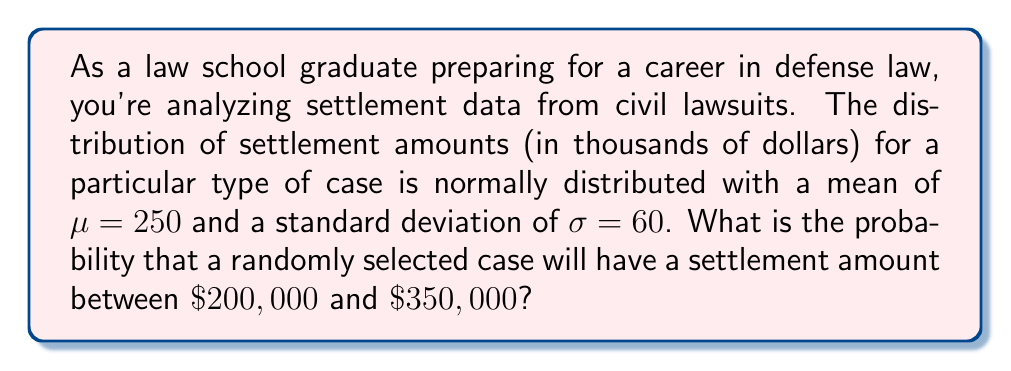Solve this math problem. To solve this problem, we'll use the properties of the normal distribution and the concept of z-scores.

1) First, we need to standardize the given values to calculate z-scores:

   For $\$200,000$: $z_1 = \frac{200 - 250}{60} = -\frac{50}{60} = -0.8333$
   For $\$350,000$: $z_2 = \frac{350 - 250}{60} = \frac{100}{60} = 1.6667$

2) Now, we need to find the area under the standard normal curve between these two z-scores.

3) We can use a standard normal table or a calculator to find the cumulative probability for each z-score:

   $P(Z \leq -0.8333) \approx 0.2023$
   $P(Z \leq 1.6667) \approx 0.9522$

4) The probability we're looking for is the difference between these two values:

   $P(-0.8333 \leq Z \leq 1.6667) = 0.9522 - 0.2023 = 0.7499$

5) Therefore, the probability that a randomly selected case will have a settlement amount between $\$200,000$ and $\$350,000$ is approximately 0.7499 or 74.99%.

This can be represented mathematically as:

$$P(200 \leq X \leq 350) = P\left(\frac{200 - 250}{60} \leq Z \leq \frac{350 - 250}{60}\right) = P(-0.8333 \leq Z \leq 1.6667) \approx 0.7499$$

Where $X$ is the random variable representing the settlement amount in thousands of dollars.
Answer: The probability is approximately 0.7499 or 74.99%. 